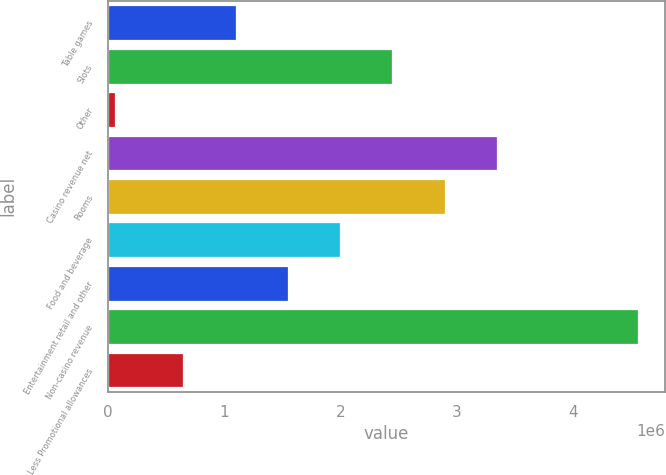Convert chart to OTSL. <chart><loc_0><loc_0><loc_500><loc_500><bar_chart><fcel>Table games<fcel>Slots<fcel>Other<fcel>Casino revenue net<fcel>Rooms<fcel>Food and beverage<fcel>Entertainment retail and other<fcel>Non-casino revenue<fcel>Less Promotional allowances<nl><fcel>1.09737e+06<fcel>2.44884e+06<fcel>60398<fcel>3.34982e+06<fcel>2.89933e+06<fcel>1.99835e+06<fcel>1.54786e+06<fcel>4.56532e+06<fcel>646874<nl></chart> 